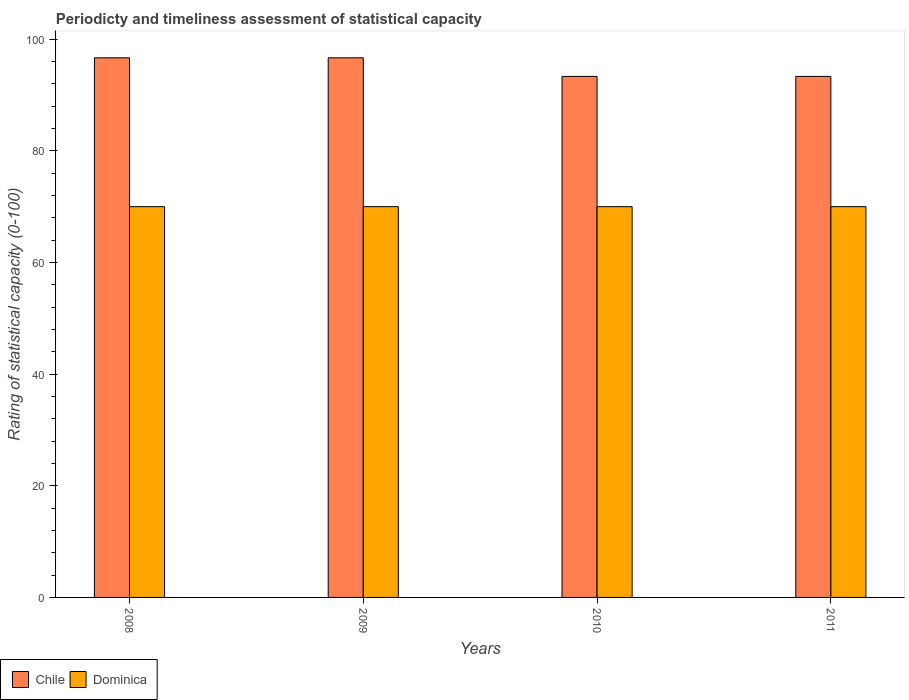How many different coloured bars are there?
Provide a short and direct response. 2. How many groups of bars are there?
Keep it short and to the point. 4. Are the number of bars per tick equal to the number of legend labels?
Offer a very short reply. Yes. How many bars are there on the 1st tick from the left?
Your response must be concise. 2. How many bars are there on the 4th tick from the right?
Keep it short and to the point. 2. What is the rating of statistical capacity in Dominica in 2011?
Your response must be concise. 70. Across all years, what is the maximum rating of statistical capacity in Chile?
Ensure brevity in your answer.  96.67. Across all years, what is the minimum rating of statistical capacity in Chile?
Make the answer very short. 93.33. In which year was the rating of statistical capacity in Chile minimum?
Make the answer very short. 2010. What is the total rating of statistical capacity in Chile in the graph?
Ensure brevity in your answer.  380. What is the difference between the rating of statistical capacity in Dominica in 2009 and that in 2011?
Offer a very short reply. 0. What is the difference between the rating of statistical capacity in Dominica in 2008 and the rating of statistical capacity in Chile in 2009?
Ensure brevity in your answer.  -26.67. What is the average rating of statistical capacity in Dominica per year?
Offer a very short reply. 70. In the year 2011, what is the difference between the rating of statistical capacity in Chile and rating of statistical capacity in Dominica?
Provide a succinct answer. 23.33. What is the ratio of the rating of statistical capacity in Chile in 2008 to that in 2010?
Your answer should be compact. 1.04. Is the rating of statistical capacity in Dominica in 2010 less than that in 2011?
Give a very brief answer. No. Is the difference between the rating of statistical capacity in Chile in 2008 and 2010 greater than the difference between the rating of statistical capacity in Dominica in 2008 and 2010?
Give a very brief answer. Yes. What is the difference between the highest and the second highest rating of statistical capacity in Dominica?
Keep it short and to the point. 0. Is the sum of the rating of statistical capacity in Chile in 2009 and 2011 greater than the maximum rating of statistical capacity in Dominica across all years?
Your answer should be very brief. Yes. How many bars are there?
Make the answer very short. 8. What is the difference between two consecutive major ticks on the Y-axis?
Offer a very short reply. 20. Are the values on the major ticks of Y-axis written in scientific E-notation?
Provide a succinct answer. No. Does the graph contain grids?
Offer a terse response. No. Where does the legend appear in the graph?
Make the answer very short. Bottom left. What is the title of the graph?
Your answer should be very brief. Periodicty and timeliness assessment of statistical capacity. What is the label or title of the X-axis?
Provide a short and direct response. Years. What is the label or title of the Y-axis?
Offer a terse response. Rating of statistical capacity (0-100). What is the Rating of statistical capacity (0-100) in Chile in 2008?
Ensure brevity in your answer.  96.67. What is the Rating of statistical capacity (0-100) of Dominica in 2008?
Offer a terse response. 70. What is the Rating of statistical capacity (0-100) of Chile in 2009?
Your answer should be compact. 96.67. What is the Rating of statistical capacity (0-100) in Chile in 2010?
Offer a terse response. 93.33. What is the Rating of statistical capacity (0-100) in Dominica in 2010?
Ensure brevity in your answer.  70. What is the Rating of statistical capacity (0-100) in Chile in 2011?
Ensure brevity in your answer.  93.33. What is the Rating of statistical capacity (0-100) of Dominica in 2011?
Offer a very short reply. 70. Across all years, what is the maximum Rating of statistical capacity (0-100) in Chile?
Offer a terse response. 96.67. Across all years, what is the minimum Rating of statistical capacity (0-100) in Chile?
Make the answer very short. 93.33. Across all years, what is the minimum Rating of statistical capacity (0-100) in Dominica?
Your answer should be compact. 70. What is the total Rating of statistical capacity (0-100) of Chile in the graph?
Your answer should be compact. 380. What is the total Rating of statistical capacity (0-100) in Dominica in the graph?
Make the answer very short. 280. What is the difference between the Rating of statistical capacity (0-100) of Chile in 2008 and that in 2009?
Offer a very short reply. 0. What is the difference between the Rating of statistical capacity (0-100) of Chile in 2008 and that in 2010?
Provide a short and direct response. 3.33. What is the difference between the Rating of statistical capacity (0-100) of Dominica in 2008 and that in 2010?
Ensure brevity in your answer.  0. What is the difference between the Rating of statistical capacity (0-100) in Chile in 2008 and that in 2011?
Make the answer very short. 3.33. What is the difference between the Rating of statistical capacity (0-100) in Dominica in 2008 and that in 2011?
Provide a succinct answer. 0. What is the difference between the Rating of statistical capacity (0-100) of Chile in 2009 and that in 2010?
Your answer should be very brief. 3.33. What is the difference between the Rating of statistical capacity (0-100) of Chile in 2009 and that in 2011?
Make the answer very short. 3.33. What is the difference between the Rating of statistical capacity (0-100) in Chile in 2010 and that in 2011?
Offer a very short reply. 0. What is the difference between the Rating of statistical capacity (0-100) in Dominica in 2010 and that in 2011?
Your answer should be compact. 0. What is the difference between the Rating of statistical capacity (0-100) in Chile in 2008 and the Rating of statistical capacity (0-100) in Dominica in 2009?
Provide a short and direct response. 26.67. What is the difference between the Rating of statistical capacity (0-100) of Chile in 2008 and the Rating of statistical capacity (0-100) of Dominica in 2010?
Offer a terse response. 26.67. What is the difference between the Rating of statistical capacity (0-100) of Chile in 2008 and the Rating of statistical capacity (0-100) of Dominica in 2011?
Make the answer very short. 26.67. What is the difference between the Rating of statistical capacity (0-100) in Chile in 2009 and the Rating of statistical capacity (0-100) in Dominica in 2010?
Provide a succinct answer. 26.67. What is the difference between the Rating of statistical capacity (0-100) of Chile in 2009 and the Rating of statistical capacity (0-100) of Dominica in 2011?
Ensure brevity in your answer.  26.67. What is the difference between the Rating of statistical capacity (0-100) in Chile in 2010 and the Rating of statistical capacity (0-100) in Dominica in 2011?
Your response must be concise. 23.33. What is the average Rating of statistical capacity (0-100) of Chile per year?
Keep it short and to the point. 95. What is the average Rating of statistical capacity (0-100) in Dominica per year?
Provide a succinct answer. 70. In the year 2008, what is the difference between the Rating of statistical capacity (0-100) of Chile and Rating of statistical capacity (0-100) of Dominica?
Your answer should be very brief. 26.67. In the year 2009, what is the difference between the Rating of statistical capacity (0-100) of Chile and Rating of statistical capacity (0-100) of Dominica?
Provide a short and direct response. 26.67. In the year 2010, what is the difference between the Rating of statistical capacity (0-100) of Chile and Rating of statistical capacity (0-100) of Dominica?
Give a very brief answer. 23.33. In the year 2011, what is the difference between the Rating of statistical capacity (0-100) in Chile and Rating of statistical capacity (0-100) in Dominica?
Offer a very short reply. 23.33. What is the ratio of the Rating of statistical capacity (0-100) of Chile in 2008 to that in 2010?
Your answer should be very brief. 1.04. What is the ratio of the Rating of statistical capacity (0-100) of Dominica in 2008 to that in 2010?
Provide a succinct answer. 1. What is the ratio of the Rating of statistical capacity (0-100) in Chile in 2008 to that in 2011?
Offer a terse response. 1.04. What is the ratio of the Rating of statistical capacity (0-100) in Chile in 2009 to that in 2010?
Give a very brief answer. 1.04. What is the ratio of the Rating of statistical capacity (0-100) of Chile in 2009 to that in 2011?
Make the answer very short. 1.04. What is the ratio of the Rating of statistical capacity (0-100) of Dominica in 2009 to that in 2011?
Ensure brevity in your answer.  1. What is the ratio of the Rating of statistical capacity (0-100) in Dominica in 2010 to that in 2011?
Provide a succinct answer. 1. What is the difference between the highest and the lowest Rating of statistical capacity (0-100) in Chile?
Provide a succinct answer. 3.33. 